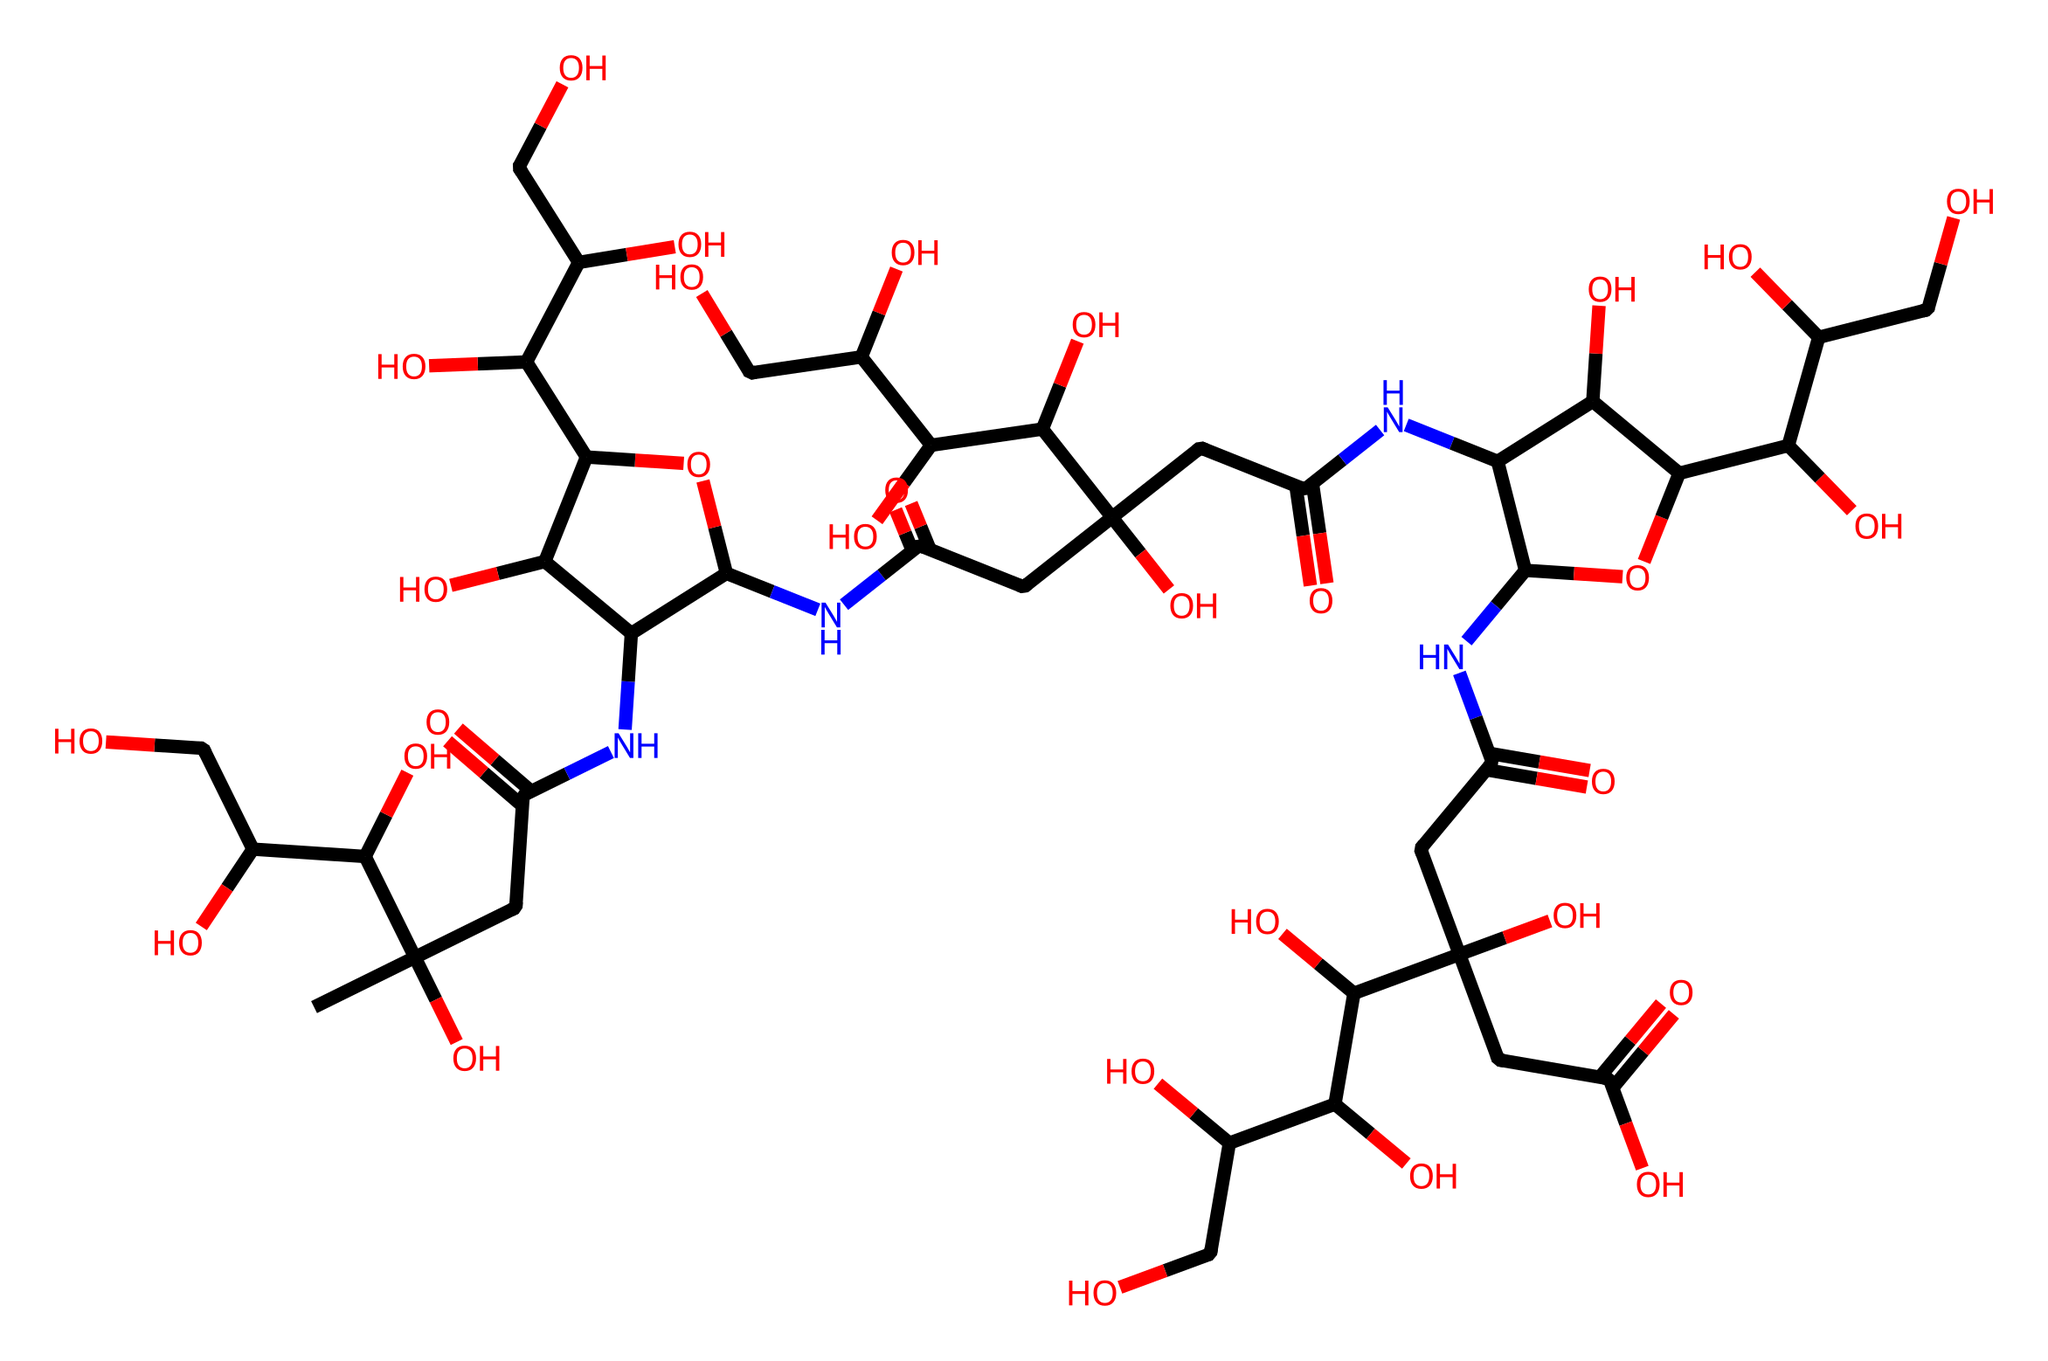What is the name of this chemical? The structure represented by the SMILES corresponds to hyaluronic acid, a glycosaminoglycan known for its hydrating properties.
Answer: hyaluronic acid How many carbon atoms are present in the structure? By analyzing the SMILES representation, we identify the carbon atoms (C). Counting each distinct carbon yields a total of 26 carbon atoms in the structure.
Answer: 26 What functional groups are found in this chemical? The structure features hydroxyl (-OH), carboxyl (-COOH), and amide (-CONH-) functional groups. These are key for the hydrating properties of hyaluronic acid.
Answer: hydroxyl, carboxyl, amide How many repeating disaccharide units are present in the structure? The structure of hyaluronic acid is based on a repeating disaccharide unit of glucuronic acid and N-acetylglucosamine. In this representation, there appear to be three repeating units.
Answer: 3 What is the role of hyaluronic acid in cosmetic formulations? Hyaluronic acid is primarily used for its hydrating capabilities, attracting and retaining moisture in the skin, leading to improved hydration and elasticity in cosmetic formulations.
Answer: hydration 